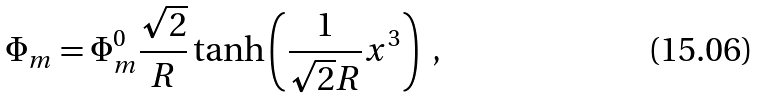<formula> <loc_0><loc_0><loc_500><loc_500>\Phi _ { m } = \Phi ^ { 0 } _ { m } \frac { \sqrt { 2 } } { R } \tanh \left ( \frac { 1 } { \sqrt { 2 } R } x ^ { 3 } \right ) \ ,</formula> 